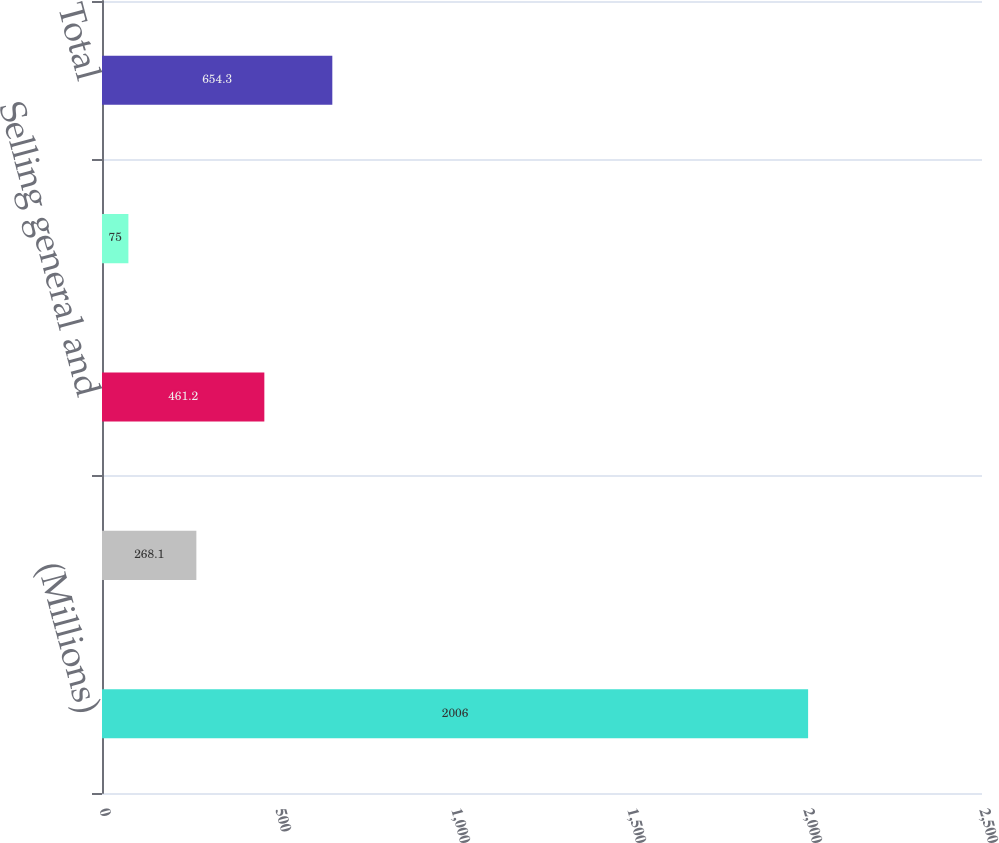Convert chart to OTSL. <chart><loc_0><loc_0><loc_500><loc_500><bar_chart><fcel>(Millions)<fcel>Cost of sales<fcel>Selling general and<fcel>Research development and<fcel>Total<nl><fcel>2006<fcel>268.1<fcel>461.2<fcel>75<fcel>654.3<nl></chart> 